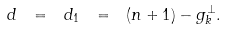<formula> <loc_0><loc_0><loc_500><loc_500>d \ = \ d _ { 1 } \ = \ ( n + 1 ) - g ^ { \perp } _ { k } .</formula> 